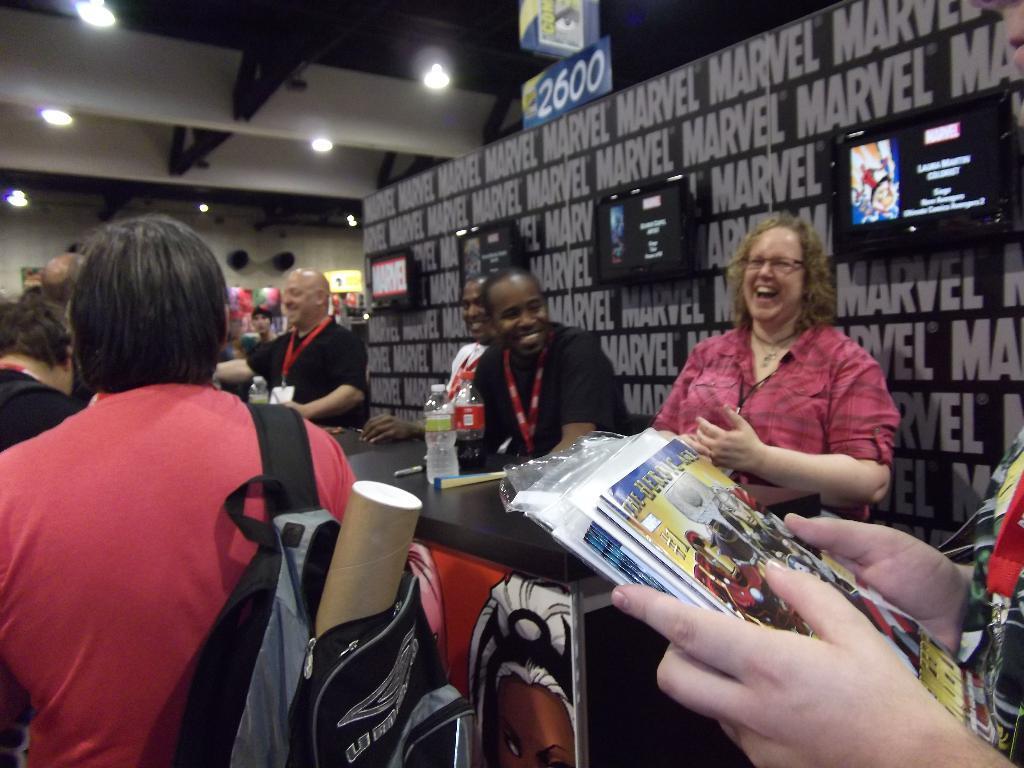Can you describe this image briefly? In this image there are people standing, in the middle there is a table on that table there are bottles, in the background there is a wall on that wall there are four screens and there is some text at the top there are lights, on the right side there is a person holding books in his hands. 